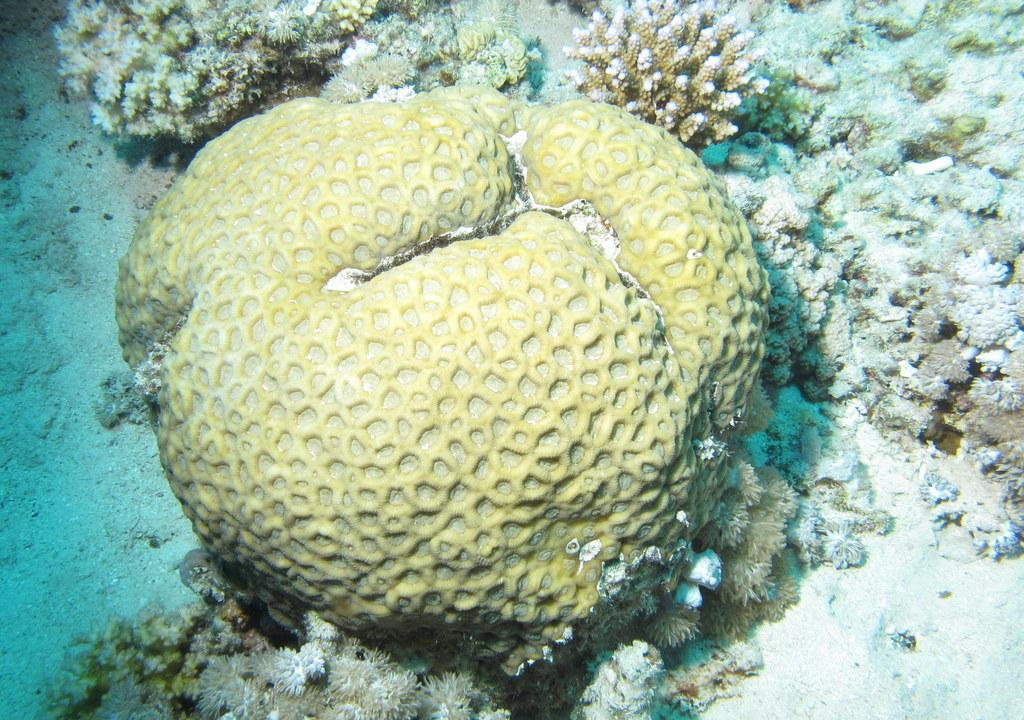What is the color of the object in the image? The object in the image has a yellow and white color. What type of plants can be seen in the image? Aquatic plants are visible in the image. How many elbows can be seen in the image? There are no elbows visible in the image. What type of bead is used to decorate the aquatic plants in the image? There are no beads present in the image, and the aquatic plants are not decorated. 